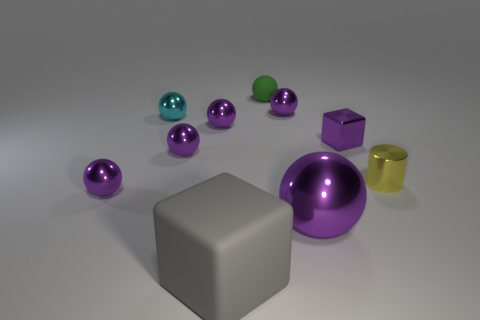Subtract all brown cubes. How many purple spheres are left? 5 Subtract all cyan balls. How many balls are left? 6 Subtract all big spheres. How many spheres are left? 6 Subtract all blue balls. Subtract all purple cubes. How many balls are left? 7 Subtract all cylinders. How many objects are left? 9 Subtract 0 gray spheres. How many objects are left? 10 Subtract all small cylinders. Subtract all tiny spheres. How many objects are left? 3 Add 7 tiny cyan shiny spheres. How many tiny cyan shiny spheres are left? 8 Add 3 small green things. How many small green things exist? 4 